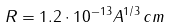Convert formula to latex. <formula><loc_0><loc_0><loc_500><loc_500>R = 1 . 2 \cdot 1 0 ^ { - 1 3 } A ^ { 1 / 3 } \, c m</formula> 